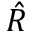<formula> <loc_0><loc_0><loc_500><loc_500>\hat { R }</formula> 